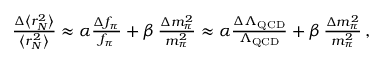Convert formula to latex. <formula><loc_0><loc_0><loc_500><loc_500>\begin{array} { r } { \, \frac { \Delta \left < r _ { N } ^ { 2 } \right > } { \left < r _ { N } ^ { 2 } \right > } \approx \alpha \frac { \Delta f _ { \pi } } { f _ { \pi } } + \beta \, \frac { \Delta m _ { \pi } ^ { 2 } } { m _ { \pi } ^ { 2 } } \approx \alpha \frac { \Delta \Lambda _ { Q C D } } { \Lambda _ { Q C D } } + \beta \, \frac { \Delta m _ { \pi } ^ { 2 } } { m _ { \pi } ^ { 2 } } \, , } \end{array}</formula> 